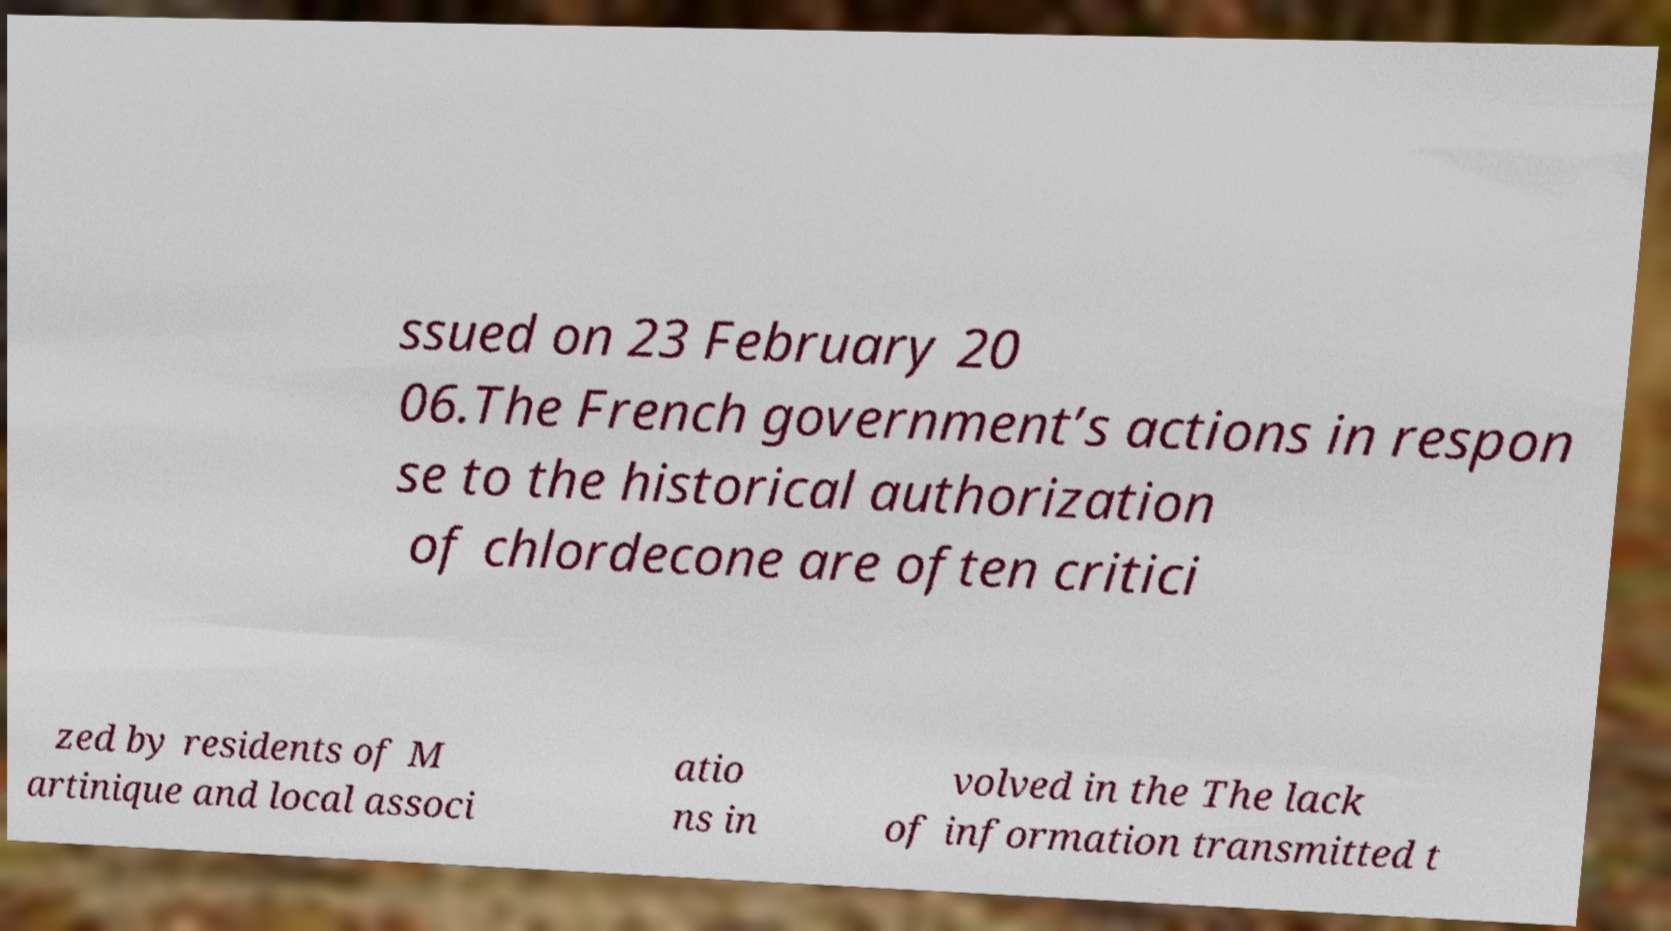Could you extract and type out the text from this image? ssued on 23 February 20 06.The French government’s actions in respon se to the historical authorization of chlordecone are often critici zed by residents of M artinique and local associ atio ns in volved in the The lack of information transmitted t 